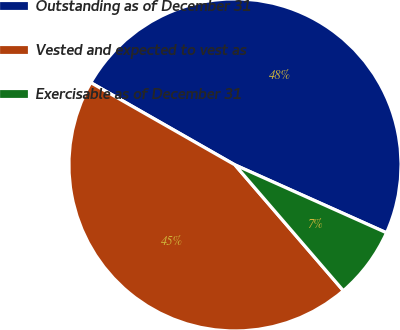Convert chart. <chart><loc_0><loc_0><loc_500><loc_500><pie_chart><fcel>Outstanding as of December 31<fcel>Vested and expected to vest as<fcel>Exercisable as of December 31<nl><fcel>48.45%<fcel>44.57%<fcel>6.98%<nl></chart> 